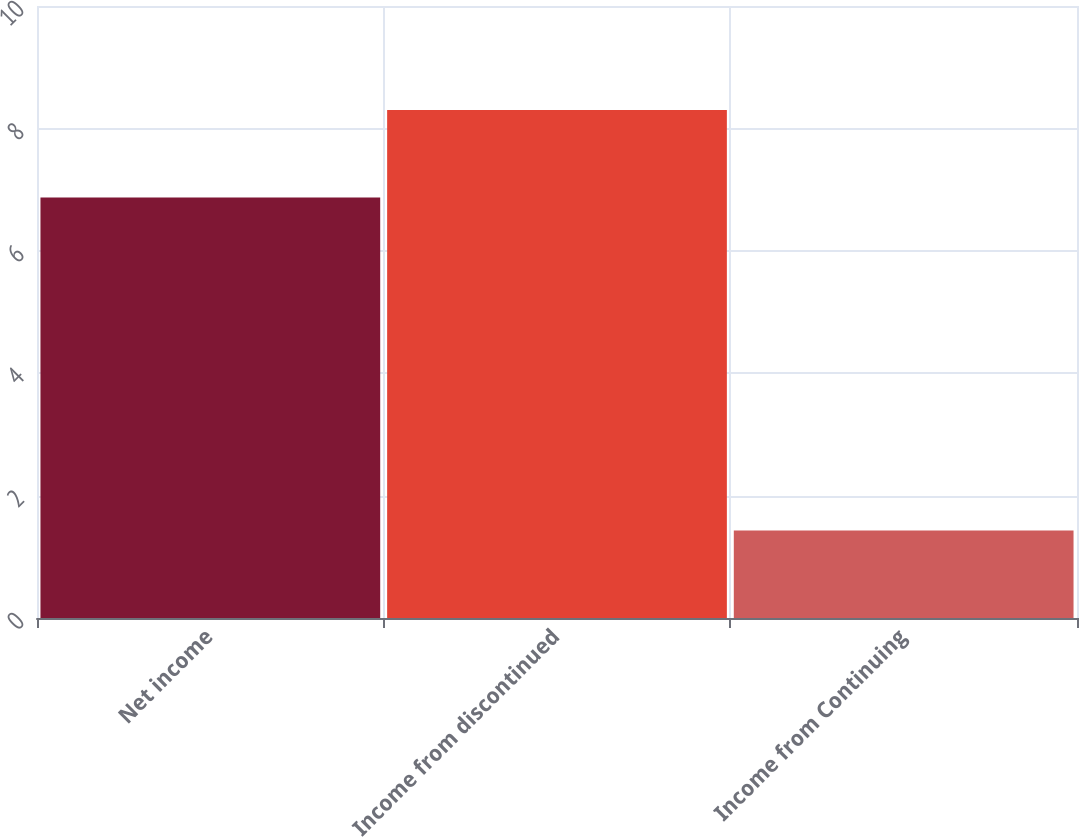Convert chart. <chart><loc_0><loc_0><loc_500><loc_500><bar_chart><fcel>Net income<fcel>Income from discontinued<fcel>Income from Continuing<nl><fcel>6.87<fcel>8.3<fcel>1.43<nl></chart> 